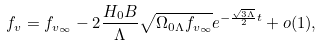Convert formula to latex. <formula><loc_0><loc_0><loc_500><loc_500>f _ { v } = f _ { v _ { \infty } } - 2 \frac { H _ { 0 } B } { \Lambda } \sqrt { { \Omega } _ { 0 \Lambda } f _ { v _ { \infty } } } e ^ { - \frac { \sqrt { 3 \Lambda } } { 2 } t } + o ( 1 ) ,</formula> 